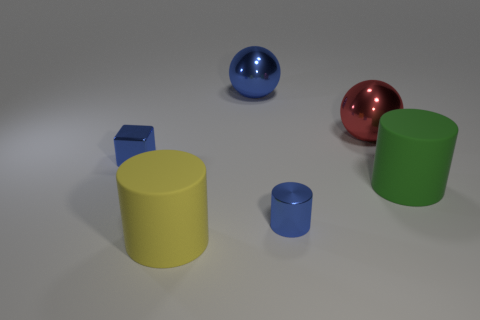Is the material of the cylinder that is behind the metallic cylinder the same as the large cylinder to the left of the green cylinder? Based on the appearance in the image, the large yellow cylinder to the left does share a similar matte surface with the smaller cylinder behind the metallic cylinder, indicating that their material properties could be the same. They lack the reflective qualities of the metallic cylinder, which distinguishes them from the shinier surfaces. 